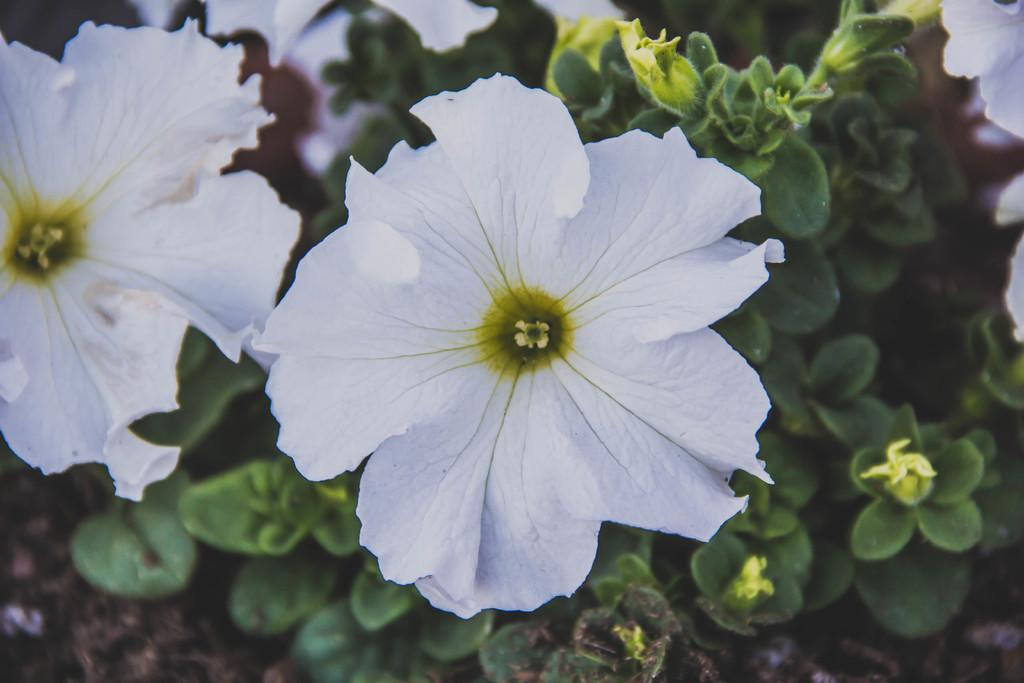What color are the flowers in the image? The flowers in the image are white. What color are the plants in the background of the image? The plants in the background of the image are green. Where are the plants located in the image? The plants are on the ground. What type of box can be seen in the image? There is no box present in the image; it features white flowers and green plants on the ground. 